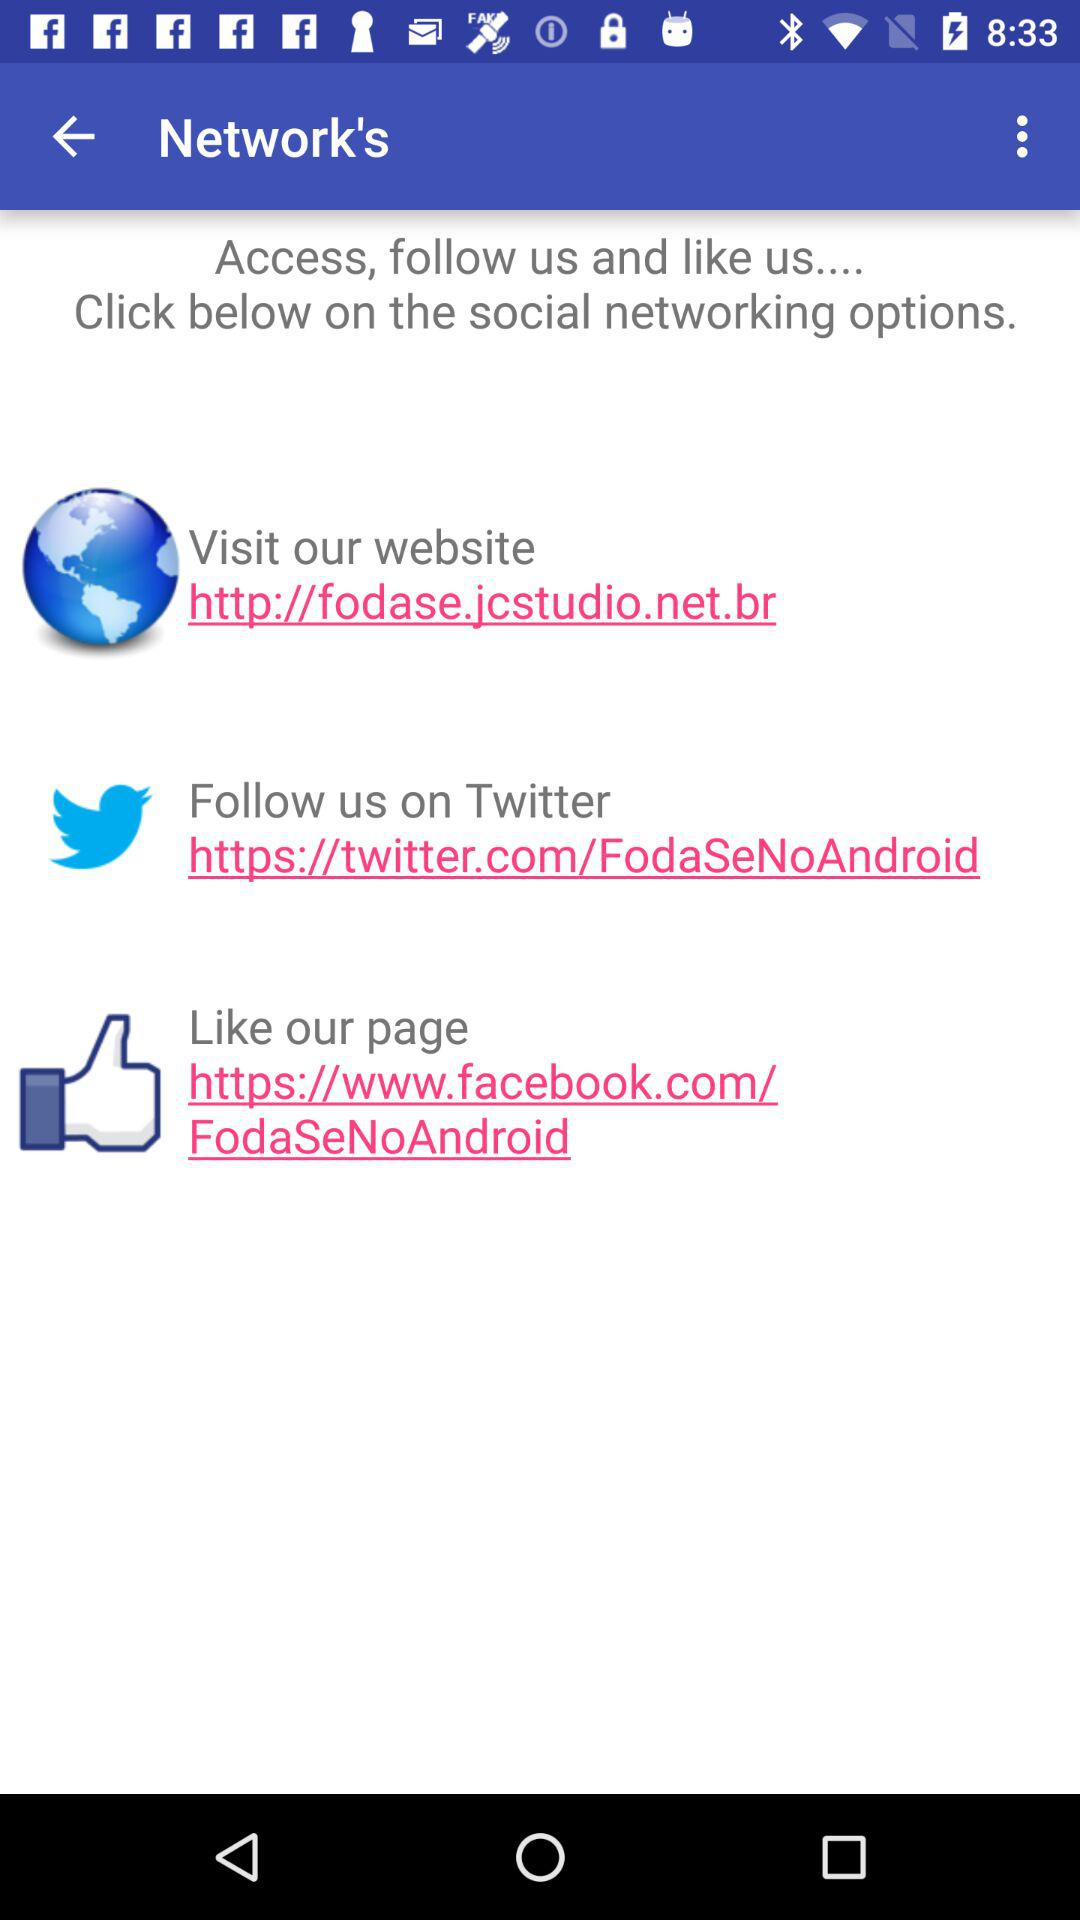How many social media options are there?
Answer the question using a single word or phrase. 3 